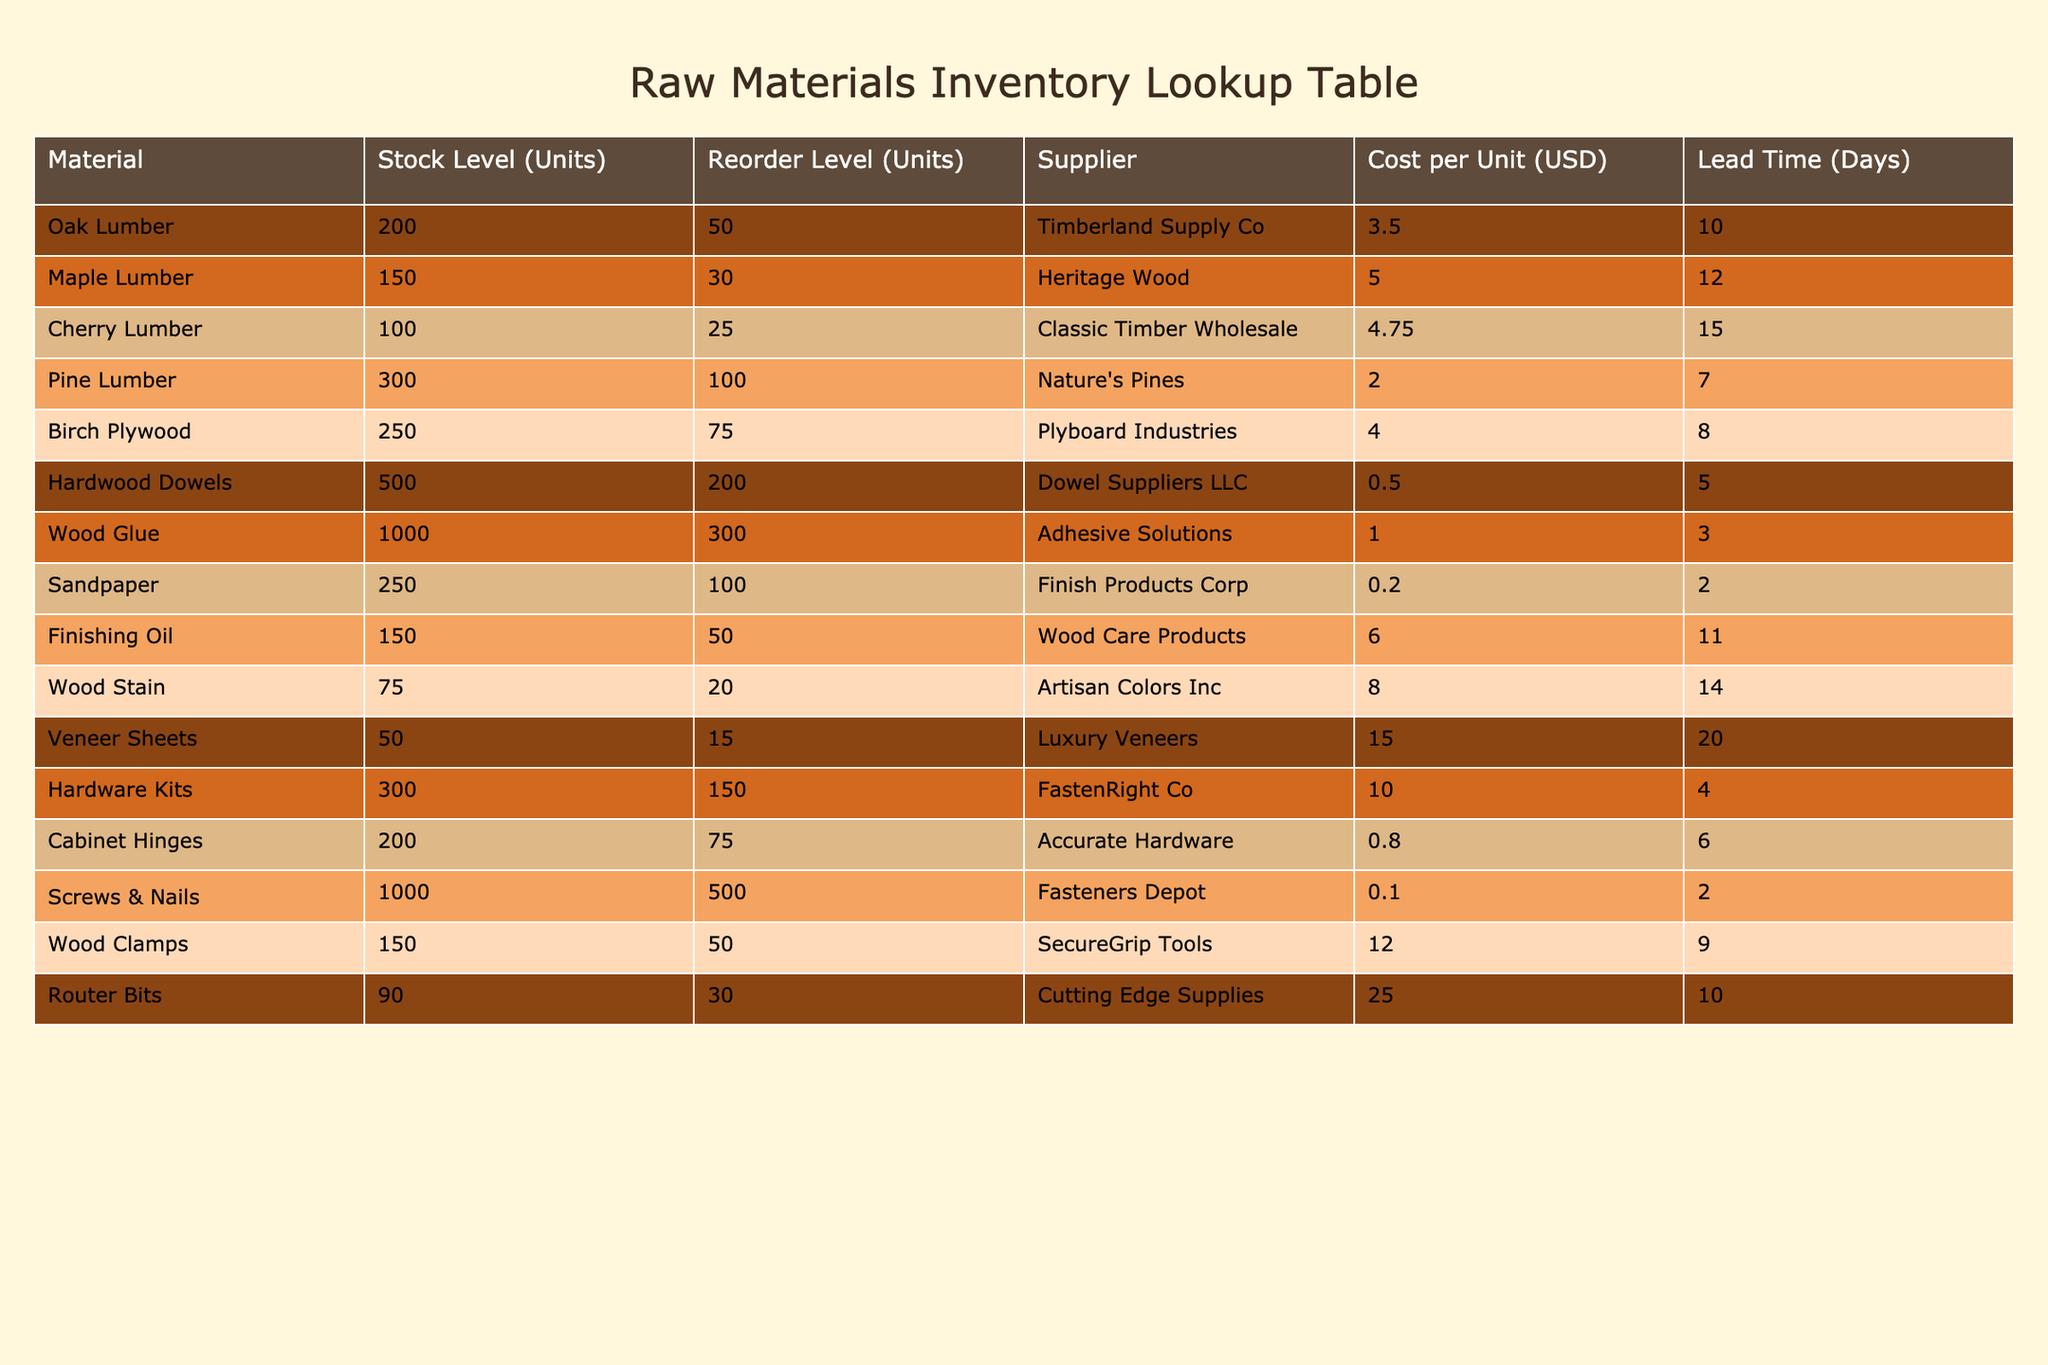What is the stock level for Oak Lumber? The stock level for Oak Lumber is directly listed in the table under the "Stock Level (Units)" column. It indicates that there are currently 200 units of Oak Lumber in inventory.
Answer: 200 Which material has the highest reorder level? By examining the "Reorder Level (Units)" column, we see that Hardwood Dowels have the highest reorder level at 200 units, which is greater than the reorder levels of all the other materials listed.
Answer: Hardwood Dowels What is the total stock level for all types of Lumber (Oak, Maple, Cherry, and Pine)? To find the total stock level for Lumber, we add the stock levels for each type: 200 (Oak) + 150 (Maple) + 100 (Cherry) + 300 (Pine) = 750 units.
Answer: 750 Is the lead time for Veneer Sheets less than or equal to 15 days? According to the table, the lead time for Veneer Sheets is 20 days, which is greater than 15 days. Therefore, the statement is false.
Answer: No What is the average cost per unit of the raw materials listed? To find the average cost per unit, we first sum the costs of all materials: (3.50 + 5.00 + 4.75 + 2.00 + 4.00 + 0.50 + 1.00 + 0.20 + 6.00 + 8.00 + 15.00 + 10.00 + 0.80 + 0.10 + 12.00 + 25.00) = 72.85. There are 16 materials, so the average cost is 72.85 / 16 = 4.553125, which we can round to 4.55.
Answer: 4.55 How many materials have a stock level less than 100 units? Checking the "Stock Level (Units)" column, we find that Cherry Lumber (100), Wood Stain (75), and Veneer Sheets (50) have stock levels less than 100. Thus, we see that only 2 materials fit the criteria: Wood Stain and Veneer Sheets.
Answer: 2 